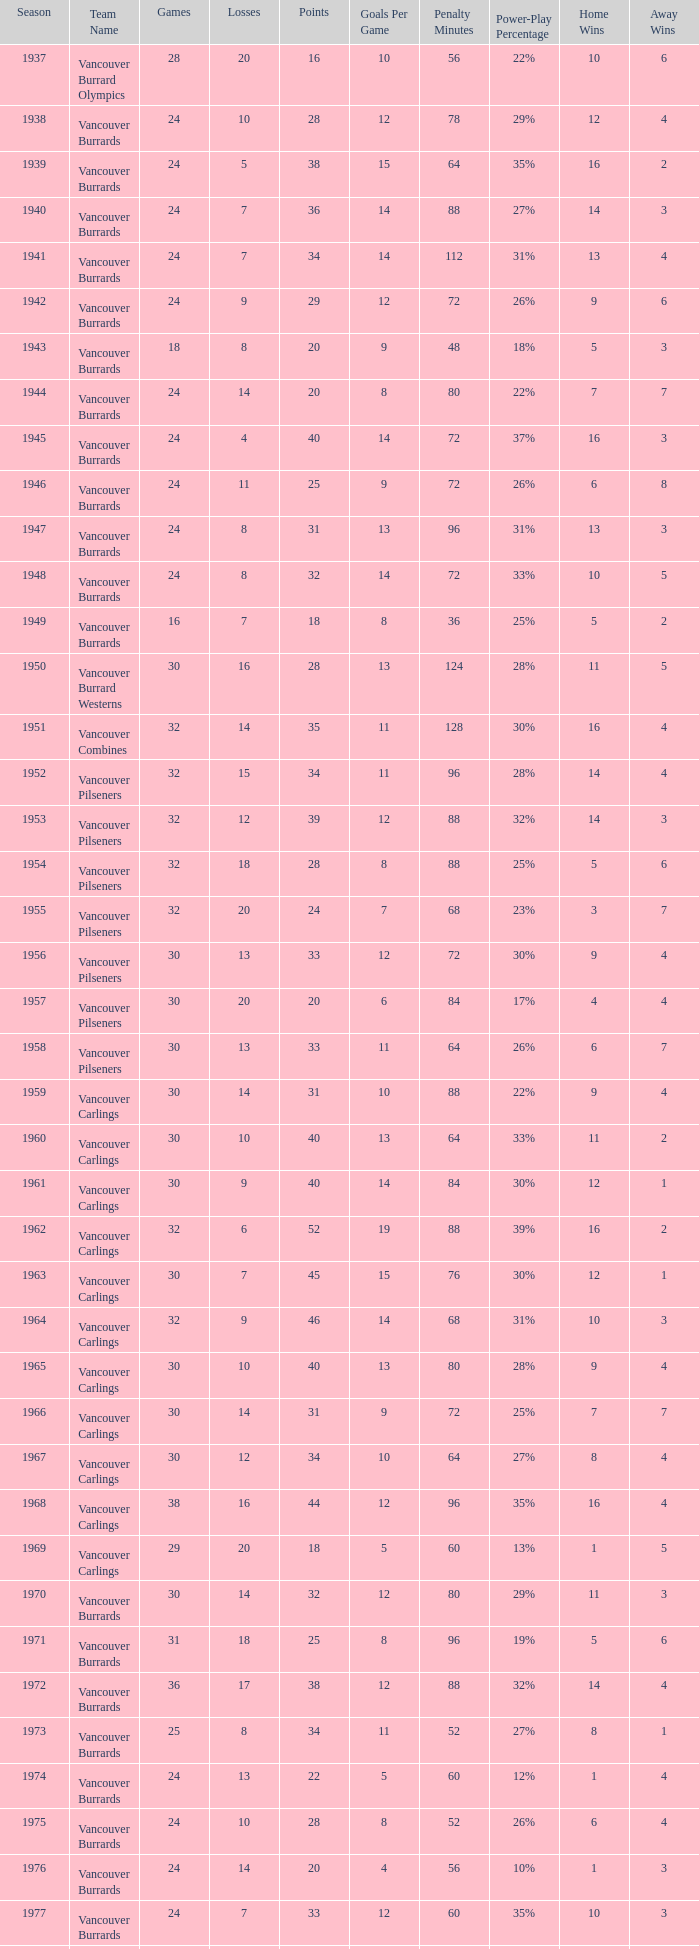What's the total number of points when the vancouver burrards have fewer than 9 losses and more than 24 games? 1.0. 